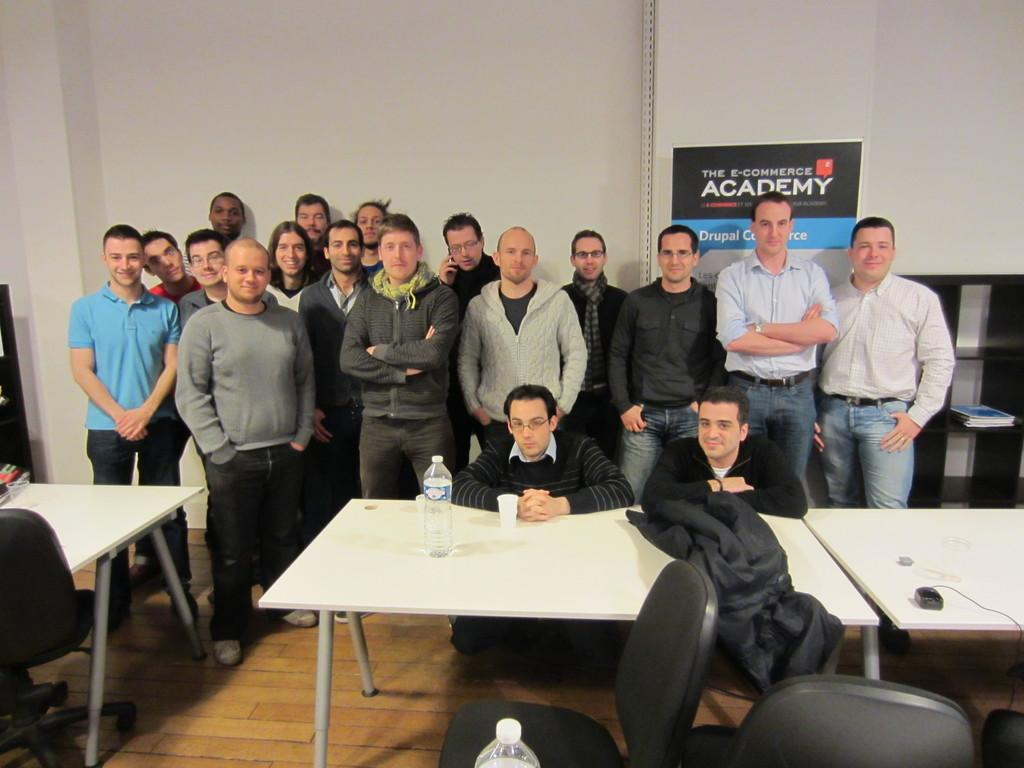How many people are in the image? There is a group of persons standing in the image. What is the surface on which the persons are standing? The persons are standing on the floor. What furniture is present in the image? There is a table and chairs in the image. What architectural feature can be seen in the image? There is a wall visible in the image. What type of quartz is being used as a tabletop in the image? There is no quartz present in the image; the tabletop material is not mentioned. Are the persons in the image wearing masks? There is no mention of masks in the image; the persons are not wearing any. 